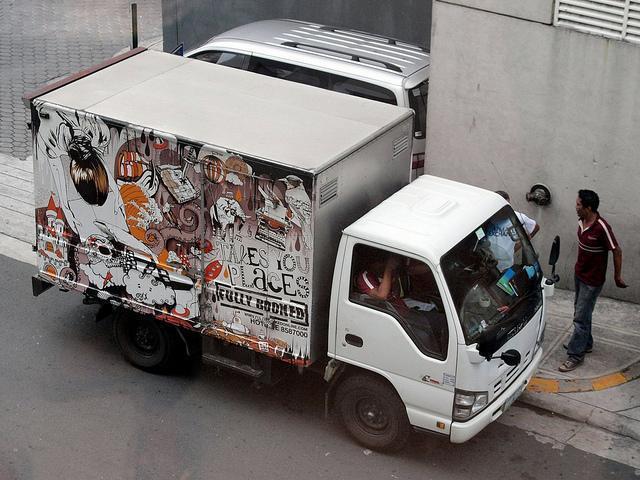How many people can be seen?
Give a very brief answer. 3. How many people are visible?
Give a very brief answer. 2. How many pair of scissors are in the picture?
Give a very brief answer. 0. 